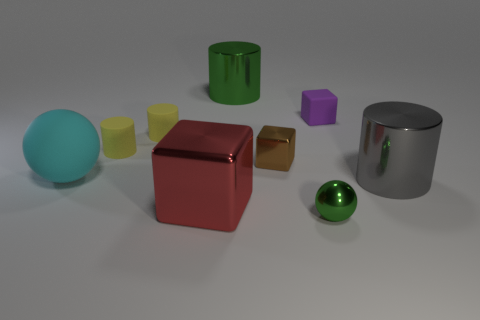Subtract all green blocks. How many yellow cylinders are left? 2 Subtract all green cylinders. How many cylinders are left? 3 Add 1 big rubber balls. How many objects exist? 10 Subtract 2 cylinders. How many cylinders are left? 2 Subtract all blocks. How many objects are left? 6 Subtract all purple cylinders. Subtract all green cubes. How many cylinders are left? 4 Subtract all blocks. Subtract all small things. How many objects are left? 1 Add 6 shiny balls. How many shiny balls are left? 7 Add 9 small metal spheres. How many small metal spheres exist? 10 Subtract 0 cyan blocks. How many objects are left? 9 